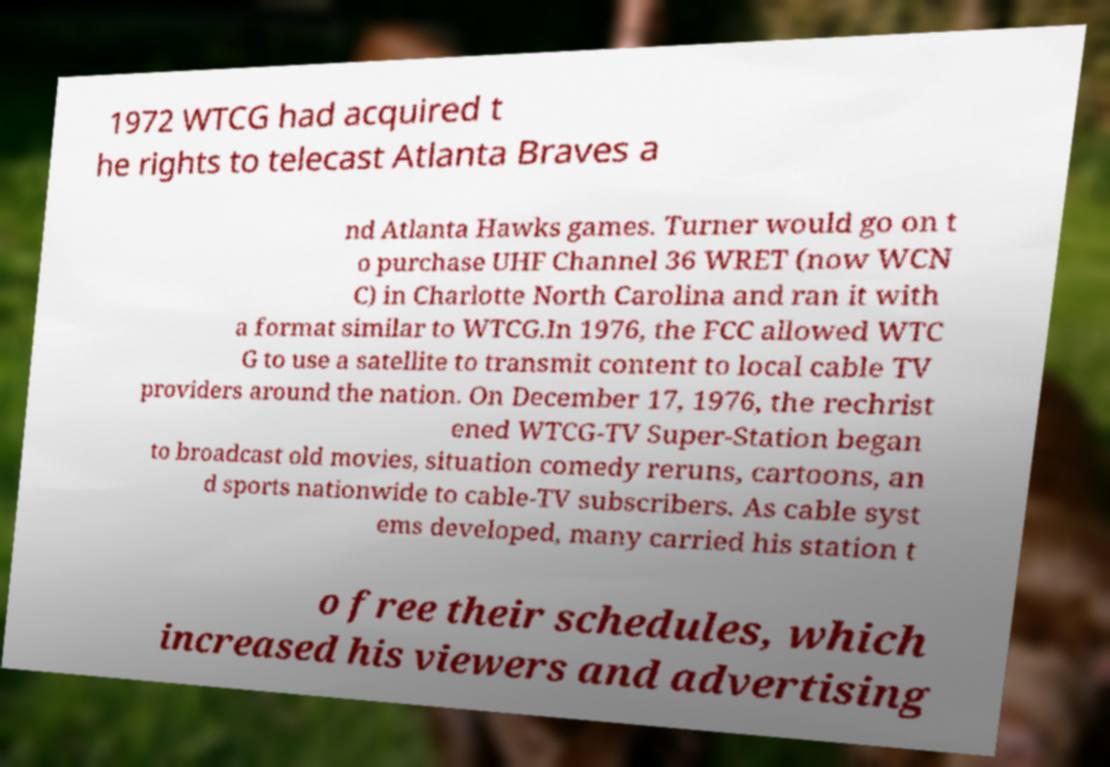For documentation purposes, I need the text within this image transcribed. Could you provide that? 1972 WTCG had acquired t he rights to telecast Atlanta Braves a nd Atlanta Hawks games. Turner would go on t o purchase UHF Channel 36 WRET (now WCN C) in Charlotte North Carolina and ran it with a format similar to WTCG.In 1976, the FCC allowed WTC G to use a satellite to transmit content to local cable TV providers around the nation. On December 17, 1976, the rechrist ened WTCG-TV Super-Station began to broadcast old movies, situation comedy reruns, cartoons, an d sports nationwide to cable-TV subscribers. As cable syst ems developed, many carried his station t o free their schedules, which increased his viewers and advertising 